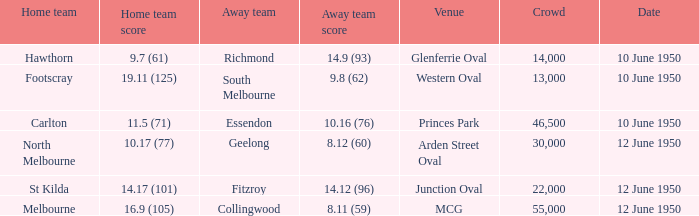What was the crowd when the VFL played MCG? 55000.0. 